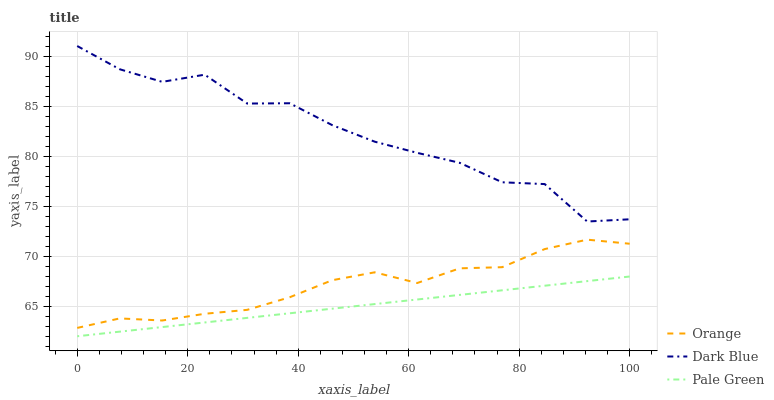Does Dark Blue have the minimum area under the curve?
Answer yes or no. No. Does Pale Green have the maximum area under the curve?
Answer yes or no. No. Is Dark Blue the smoothest?
Answer yes or no. No. Is Pale Green the roughest?
Answer yes or no. No. Does Dark Blue have the lowest value?
Answer yes or no. No. Does Pale Green have the highest value?
Answer yes or no. No. Is Orange less than Dark Blue?
Answer yes or no. Yes. Is Orange greater than Pale Green?
Answer yes or no. Yes. Does Orange intersect Dark Blue?
Answer yes or no. No. 